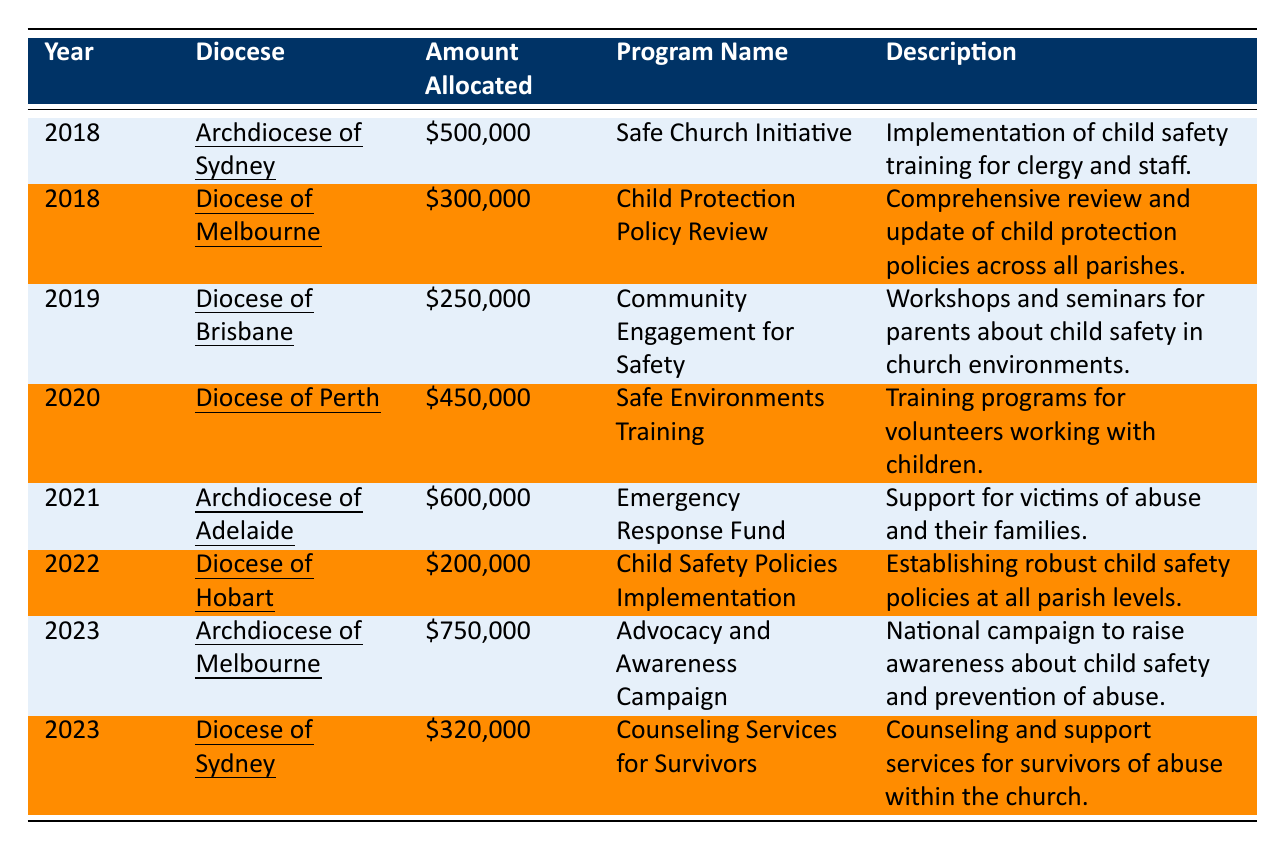What was the total amount allocated for child safety programs in 2021? The table lists the amount allocated for the Archdiocese of Adelaide in 2021 as \$600,000; therefore, that is the total amount allocated in that year.
Answer: \$600,000 Which diocese received the lowest funding allocation in 2022? According to the table, the Diocese of Hobart received \$200,000, which is less than any other diocese in 2022.
Answer: Diocese of Hobart How much funding was allocated to the Archdiocese of Melbourne in 2023? The table indicates that the Archdiocese of Melbourne was allocated \$750,000 for the Advocacy and Awareness Campaign in 2023.
Answer: \$750,000 What is the total amount allocated for all years listed in the table? To calculate the total, we sum the amounts from each entry: 500000 + 300000 + 250000 + 450000 + 600000 + 200000 + 750000 + 320000 = 3070000.
Answer: \$3,070,000 Did the Diocese of Sydney receive funding for child safety initiatives in both 2018 and 2023? Yes, the Diocese of Sydney received \$500,000 in 2018 and \$320,000 in 2023, indicating they had allocations in both years.
Answer: Yes Which year saw the highest funding allocation, and how much was it? The table shows that 2023 had the highest allocation of \$750,000 to the Archdiocese of Melbourne for an advocacy campaign, making it the year with the highest funding.
Answer: 2023, \$750,000 What is the average amount allocated per year from 2018 to 2023? We first add up the total allocations (3070000), then divide by the number of years (6: 2018, 2019, 2020, 2021, 2022, 2023), giving us 3070000/6, which equals approximately 511667.
Answer: \$511,667 How many different programs were funded across all years? By examining the table, we can count each unique program name listed: there are 8 distinct programs listed, which means 8 different programs were funded.
Answer: 8 What program was established in 2019, and how much funding did it receive? The table states that in 2019, the Diocese of Brisbane established the "Community Engagement for Safety" program, which received \$250,000 in funding.
Answer: Community Engagement for Safety, \$250,000 Which diocese had a higher allocation in 2023, and by how much? The Archdiocese of Melbourne received \$750,000 and the Diocese of Sydney received \$320,000 in 2023. The difference in allocation is \$750,000 - \$320,000 = \$430,000.
Answer: Archdiocese of Melbourne by \$430,000 